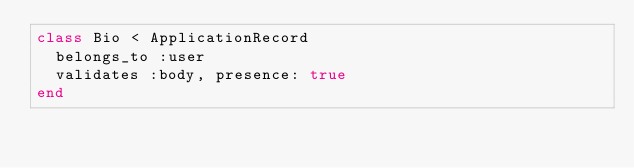Convert code to text. <code><loc_0><loc_0><loc_500><loc_500><_Ruby_>class Bio < ApplicationRecord
  belongs_to :user
  validates :body, presence: true
end
</code> 